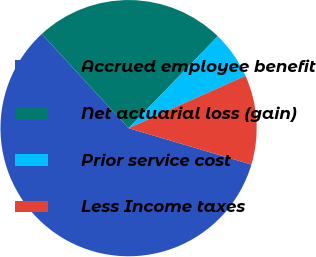<chart> <loc_0><loc_0><loc_500><loc_500><pie_chart><fcel>Accrued employee benefit<fcel>Net actuarial loss (gain)<fcel>Prior service cost<fcel>Less Income taxes<nl><fcel>58.57%<fcel>24.12%<fcel>6.03%<fcel>11.28%<nl></chart> 